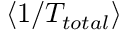<formula> <loc_0><loc_0><loc_500><loc_500>\langle 1 / T _ { t o t a l } \rangle</formula> 